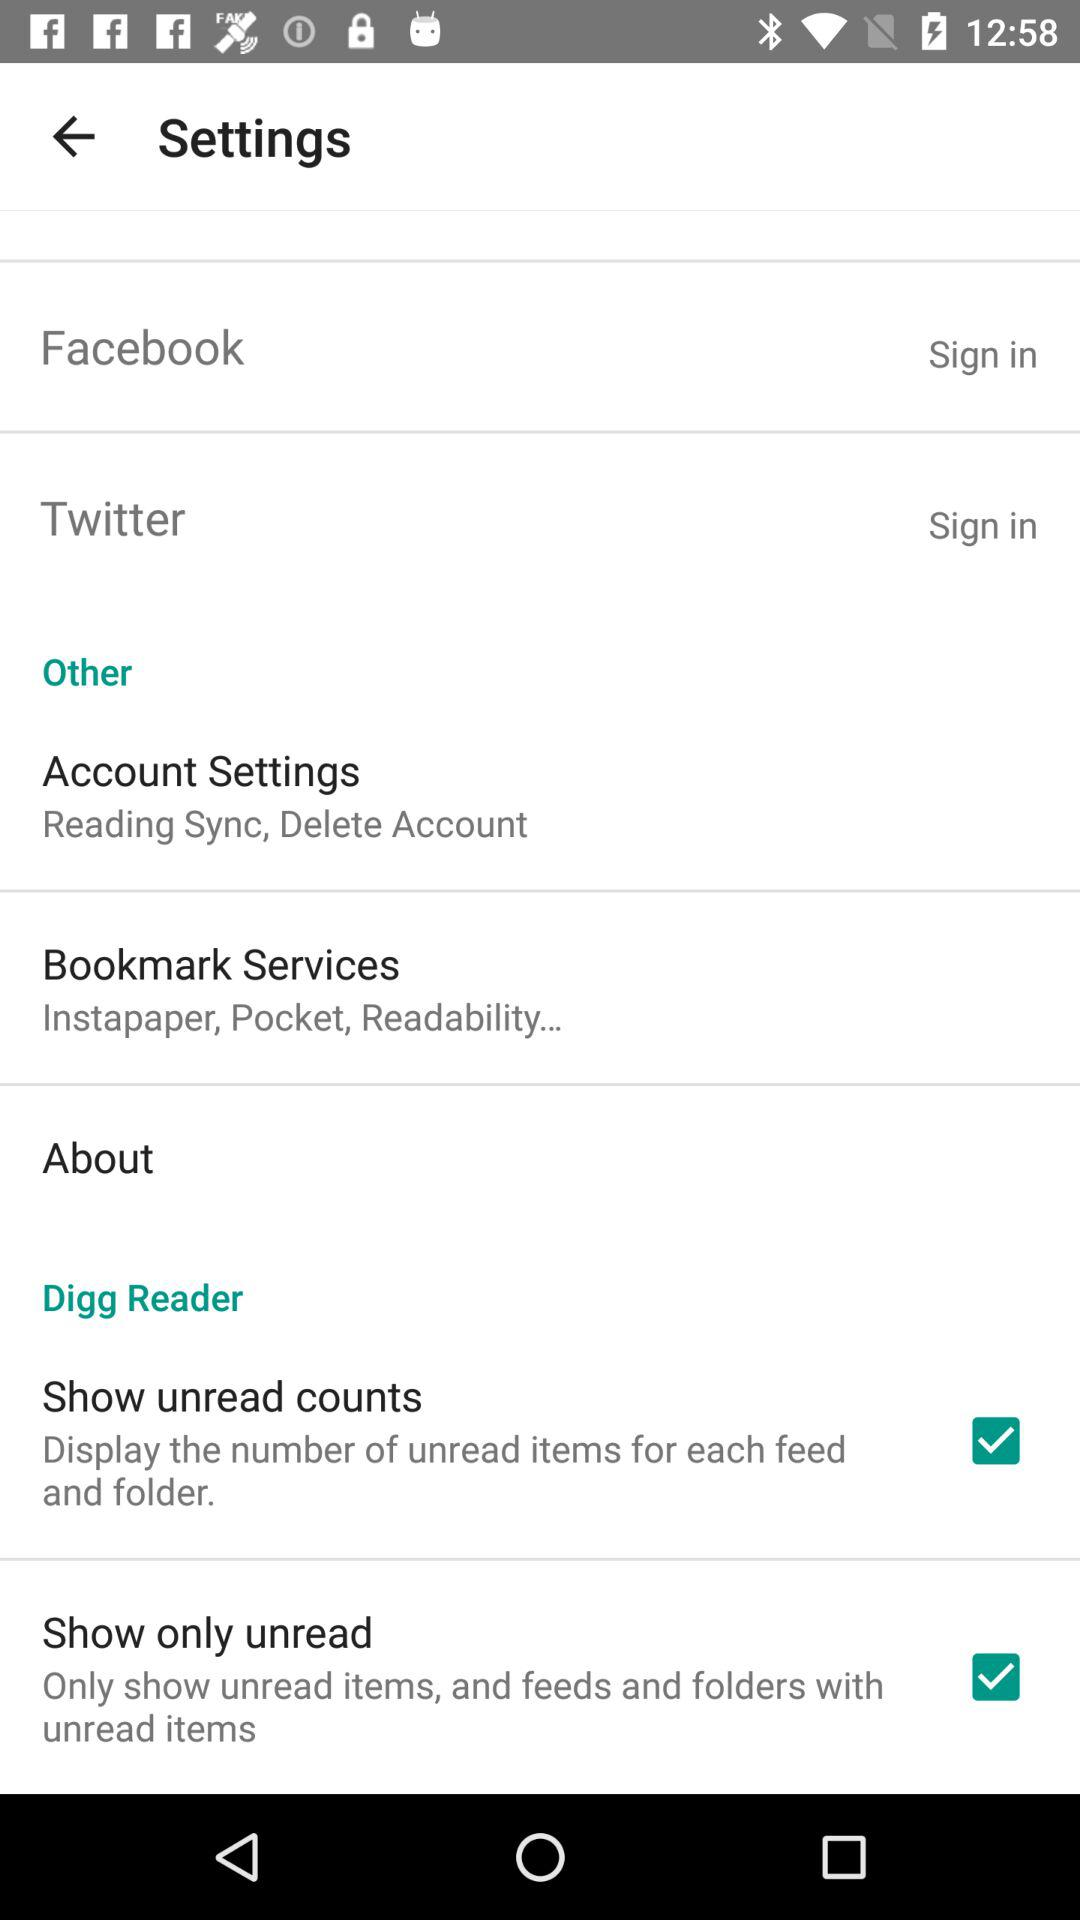Through which applications can we sign in? You can sign in through "Facebook" and "Twitter". 